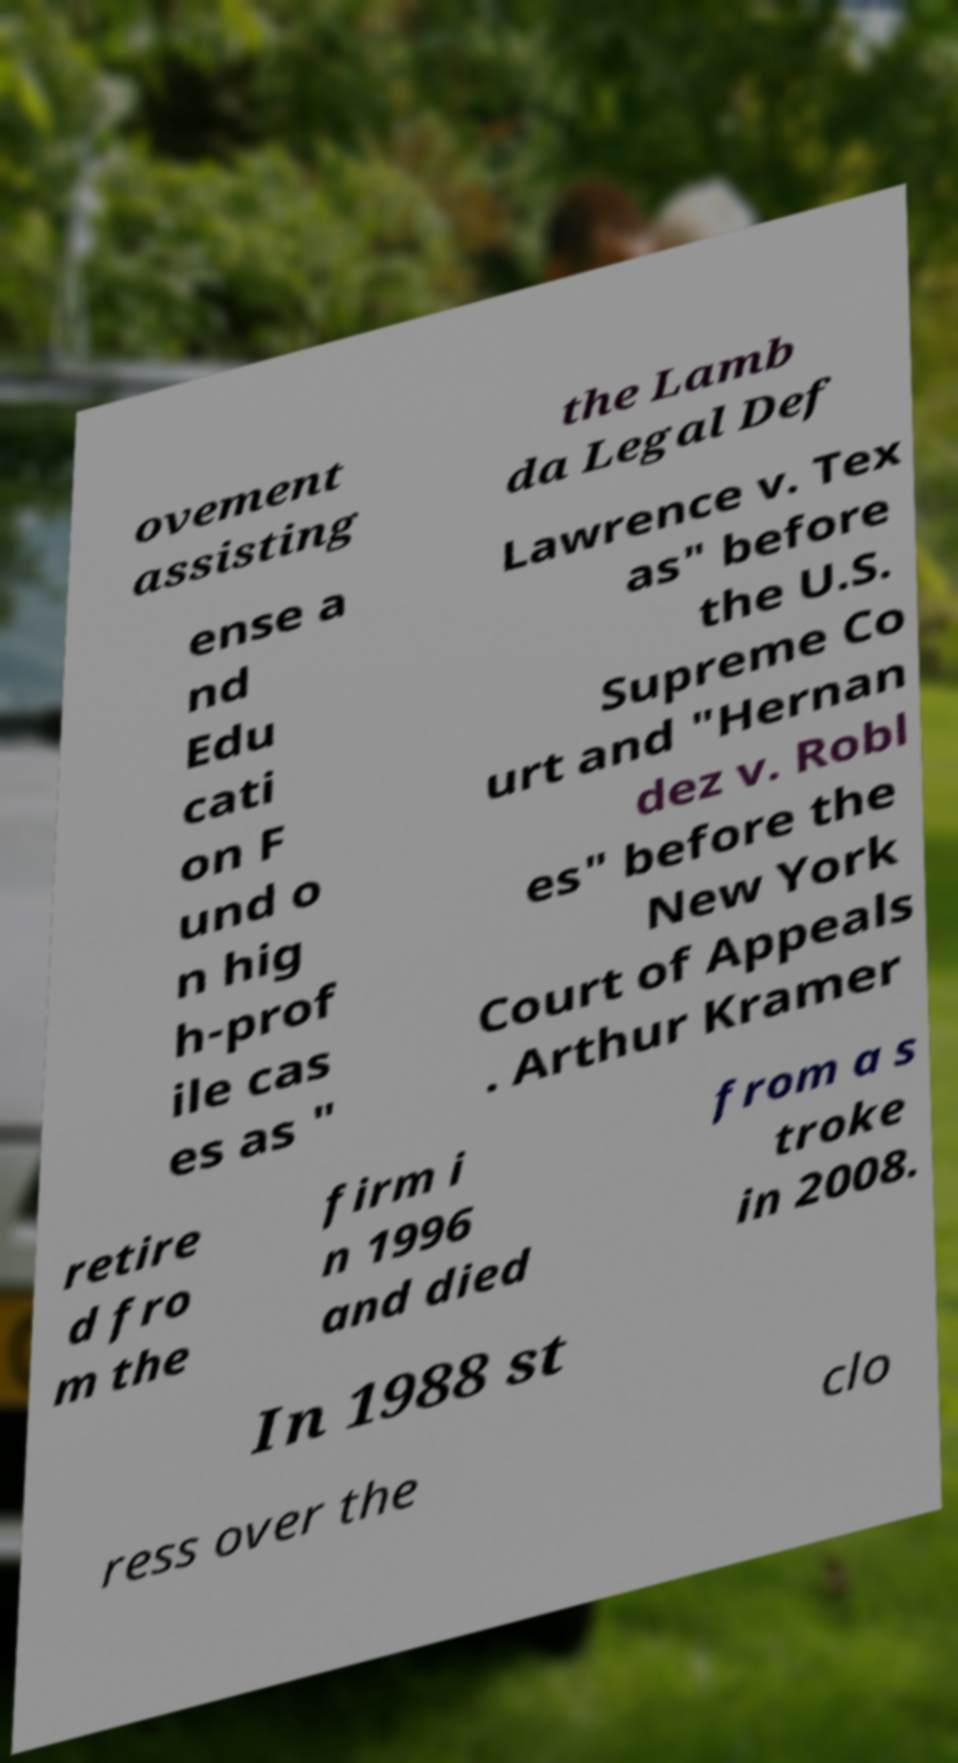Can you accurately transcribe the text from the provided image for me? ovement assisting the Lamb da Legal Def ense a nd Edu cati on F und o n hig h-prof ile cas es as " Lawrence v. Tex as" before the U.S. Supreme Co urt and "Hernan dez v. Robl es" before the New York Court of Appeals . Arthur Kramer retire d fro m the firm i n 1996 and died from a s troke in 2008. In 1988 st ress over the clo 